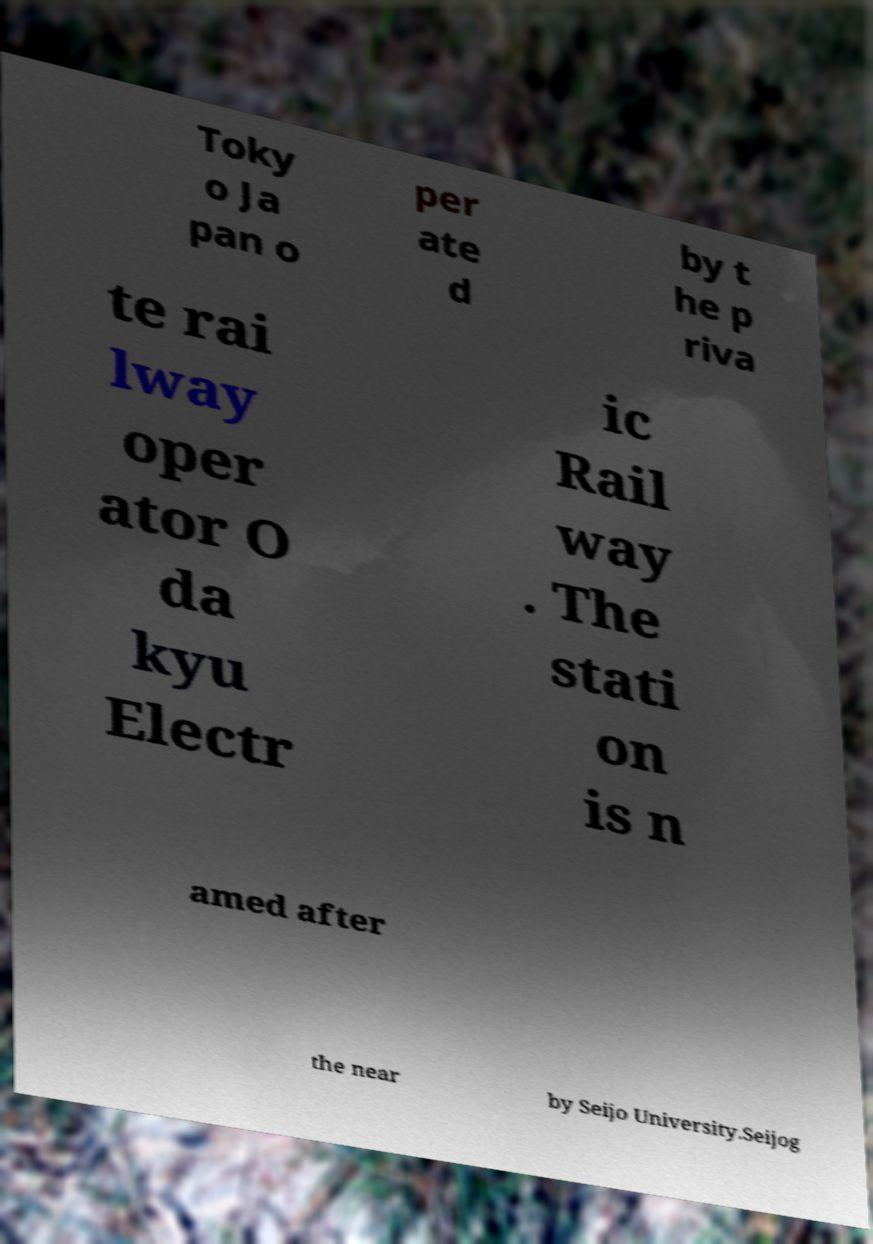There's text embedded in this image that I need extracted. Can you transcribe it verbatim? Toky o Ja pan o per ate d by t he p riva te rai lway oper ator O da kyu Electr ic Rail way . The stati on is n amed after the near by Seijo University.Seijog 